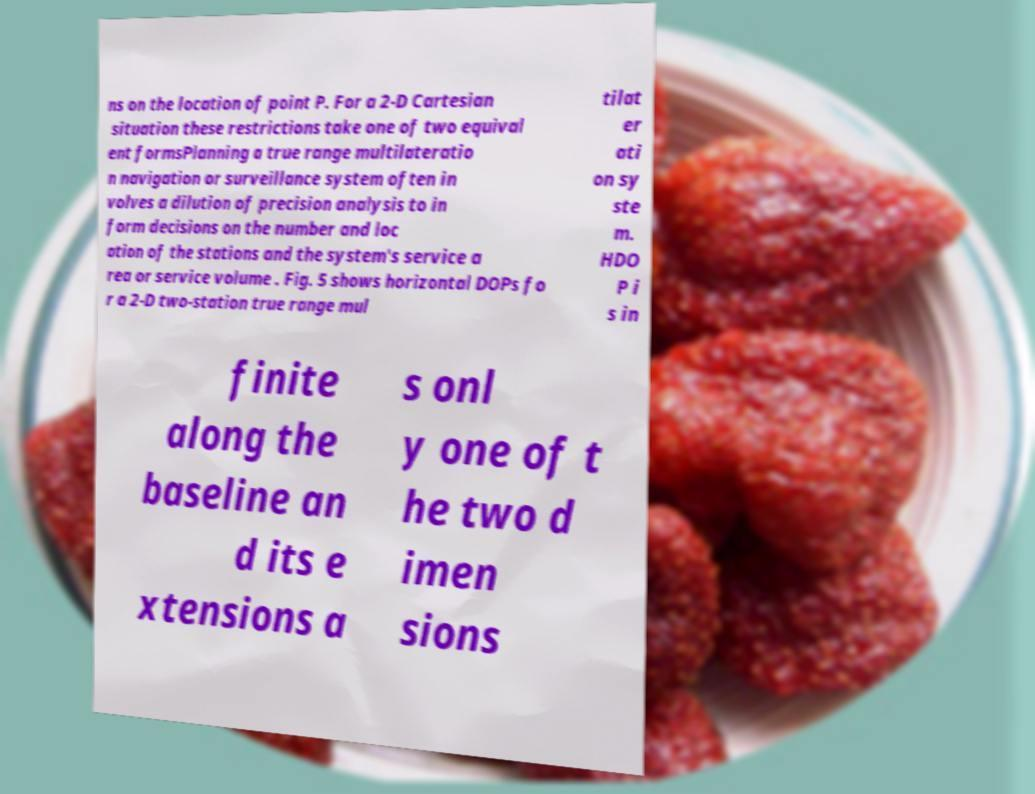I need the written content from this picture converted into text. Can you do that? ns on the location of point P. For a 2-D Cartesian situation these restrictions take one of two equival ent formsPlanning a true range multilateratio n navigation or surveillance system often in volves a dilution of precision analysis to in form decisions on the number and loc ation of the stations and the system's service a rea or service volume . Fig. 5 shows horizontal DOPs fo r a 2-D two-station true range mul tilat er ati on sy ste m. HDO P i s in finite along the baseline an d its e xtensions a s onl y one of t he two d imen sions 